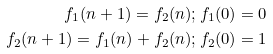Convert formula to latex. <formula><loc_0><loc_0><loc_500><loc_500>f _ { 1 } ( n + 1 ) = f _ { 2 } ( n ) ; f _ { 1 } ( 0 ) = 0 \\ f _ { 2 } ( n + 1 ) = f _ { 1 } ( n ) + f _ { 2 } ( n ) ; f _ { 2 } ( 0 ) = 1</formula> 